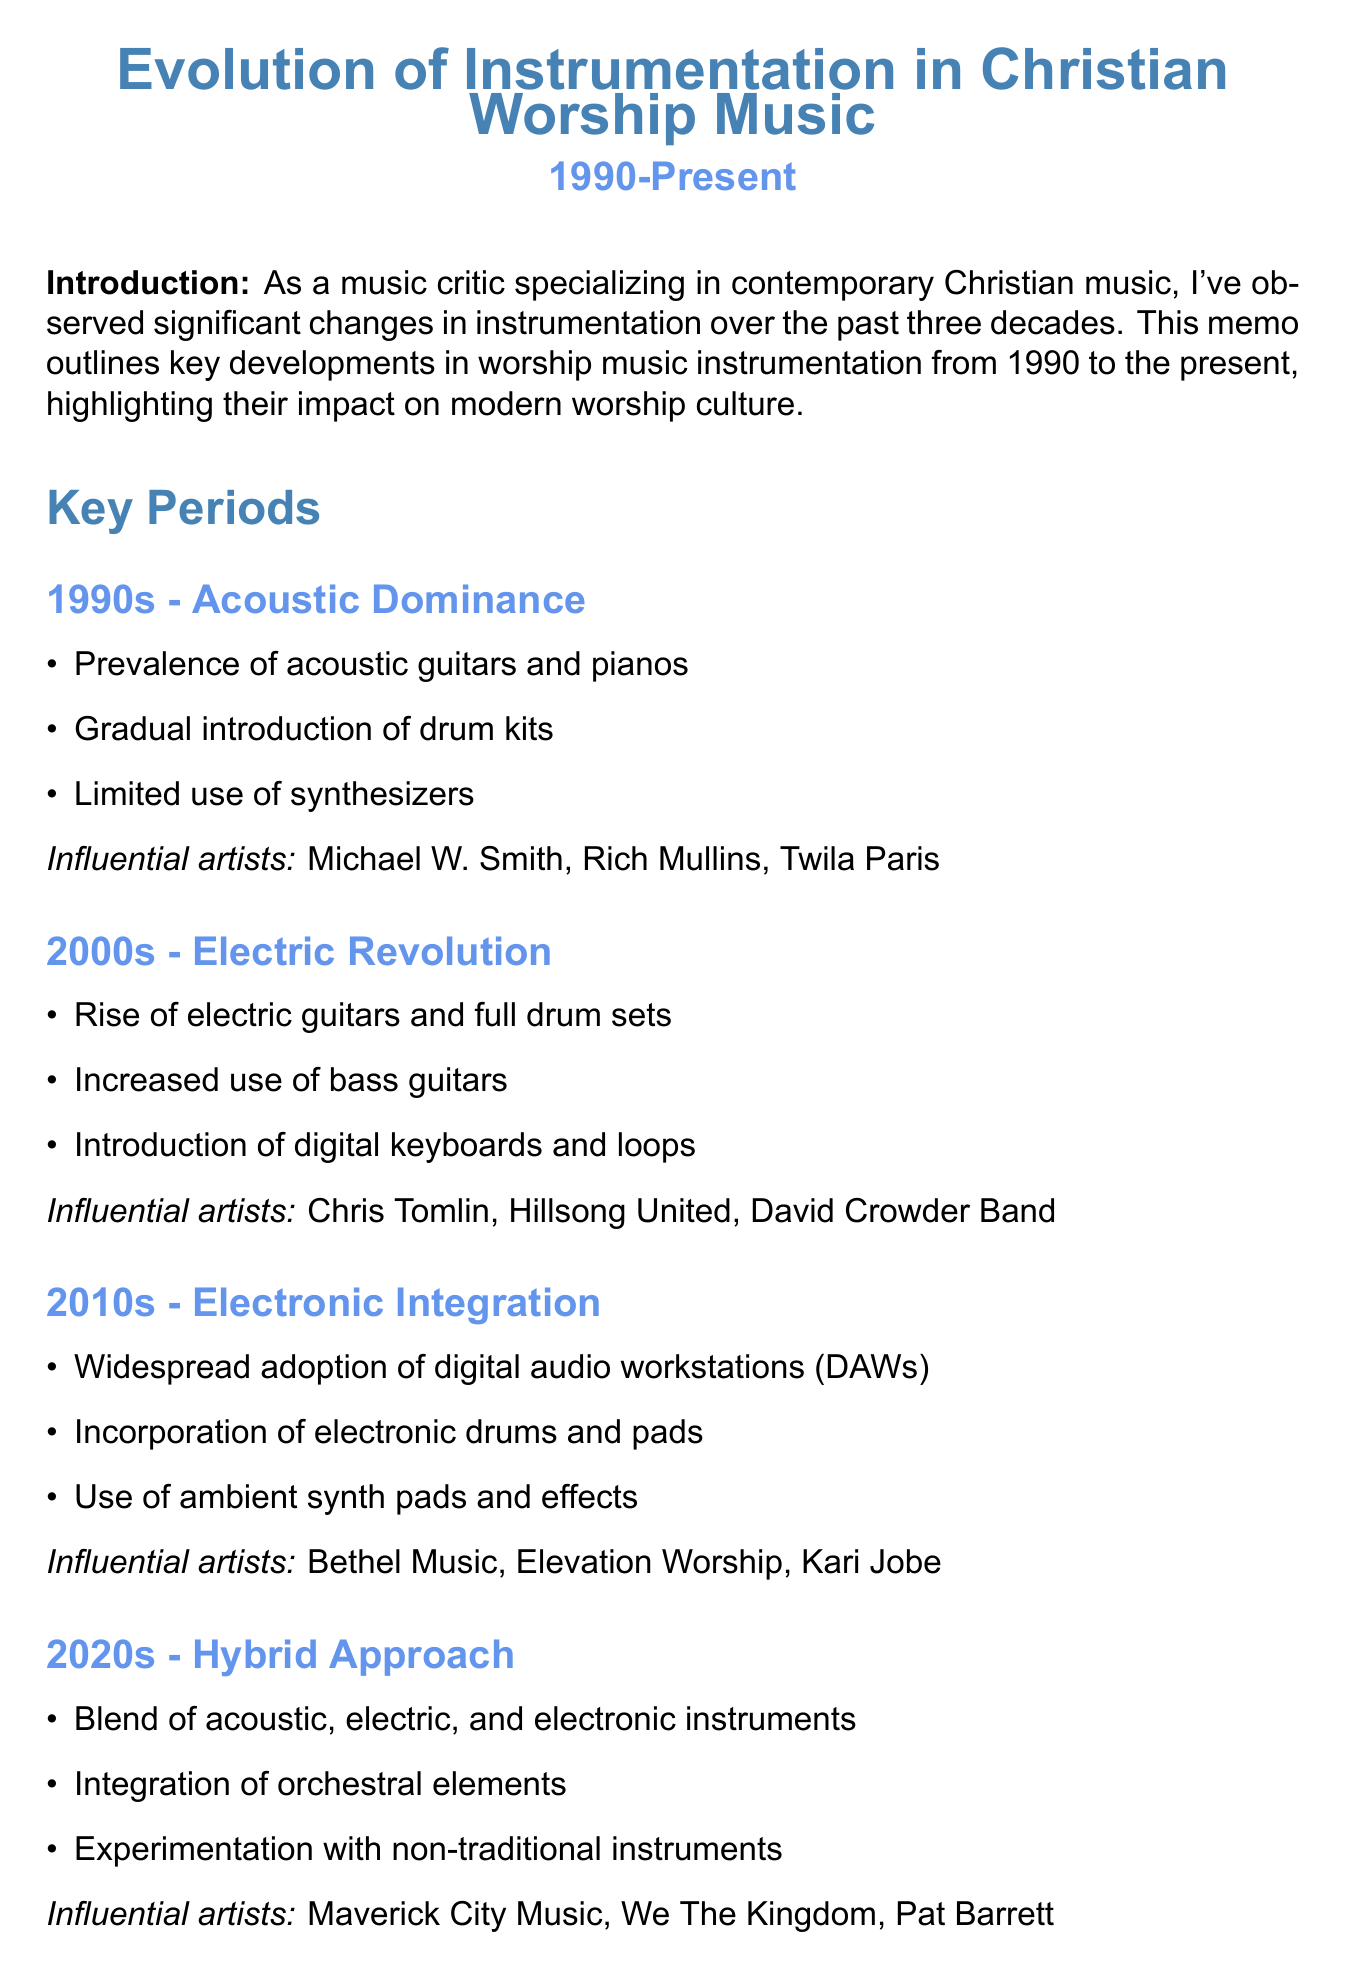What dominated instrumentation in the 1990s? The document states that the 1990s era was characterized by the prevalence of acoustic guitars and pianos.
Answer: Acoustic guitars and pianos Which influential artist is associated with the 2000s era? The document lists Chris Tomlin as one of the influential artists in the 2000s era of Christian worship music.
Answer: Chris Tomlin What technology enabled complex arrangements in live settings? The memo mentions Digital Audio Workstations as a technological influence that enabled complex arrangements.
Answer: Digital Audio Workstations How did congregational participation change over the years? The document notes the shift from hymnal-based singing to projection screens and more complex musical arrangements for congregational participation.
Answer: Shift from hymnal-based singing to projection screens Which aspect of worship culture is highlighted by increased demand for skilled musicians? The document makes it clear that the increased demand for skilled musicians pertains to the aspect of church music teams in worship culture.
Answer: Church Music Teams What era introduced the integration of orchestral elements? The memo details that the 2020s era embraced a hybrid approach which includes orchestral elements.
Answer: 2020s What is the main focus of the evolution of instrumentation in worship music? The conclusion of the document states that the evolution reflects broader trends while maintaining a focus on facilitating communal worship experiences.
Answer: Facilitating communal worship experiences What type of approach is characterized by blending traditional and contemporary elements? The document describes the 2020s as a hybrid approach that integrates traditional and contemporary elements.
Answer: Hybrid Approach 